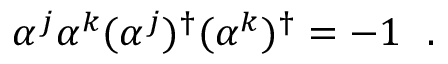<formula> <loc_0><loc_0><loc_500><loc_500>\alpha ^ { j } \alpha ^ { k } ( \alpha ^ { j } ) ^ { \dagger } ( \alpha ^ { k } ) ^ { \dagger } = - 1 .</formula> 